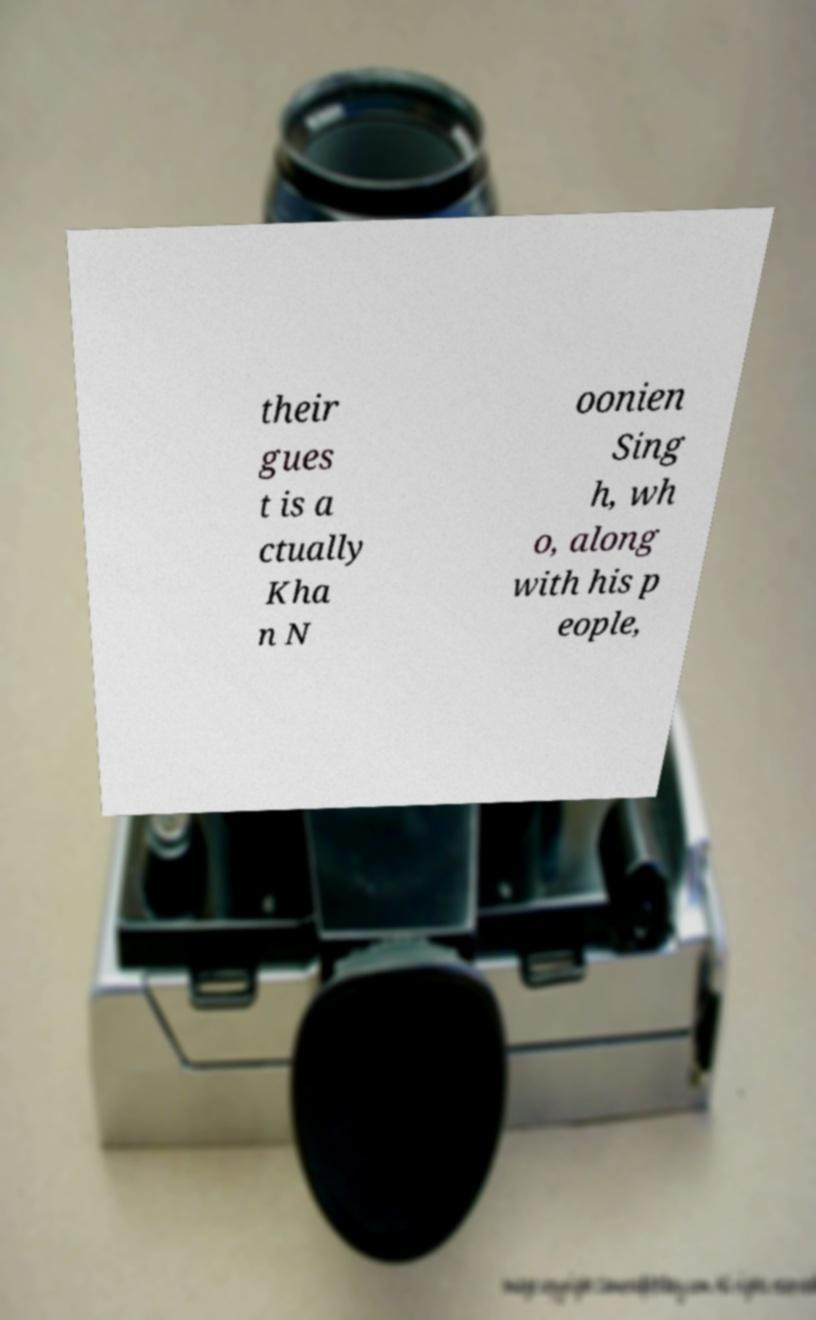Could you assist in decoding the text presented in this image and type it out clearly? their gues t is a ctually Kha n N oonien Sing h, wh o, along with his p eople, 